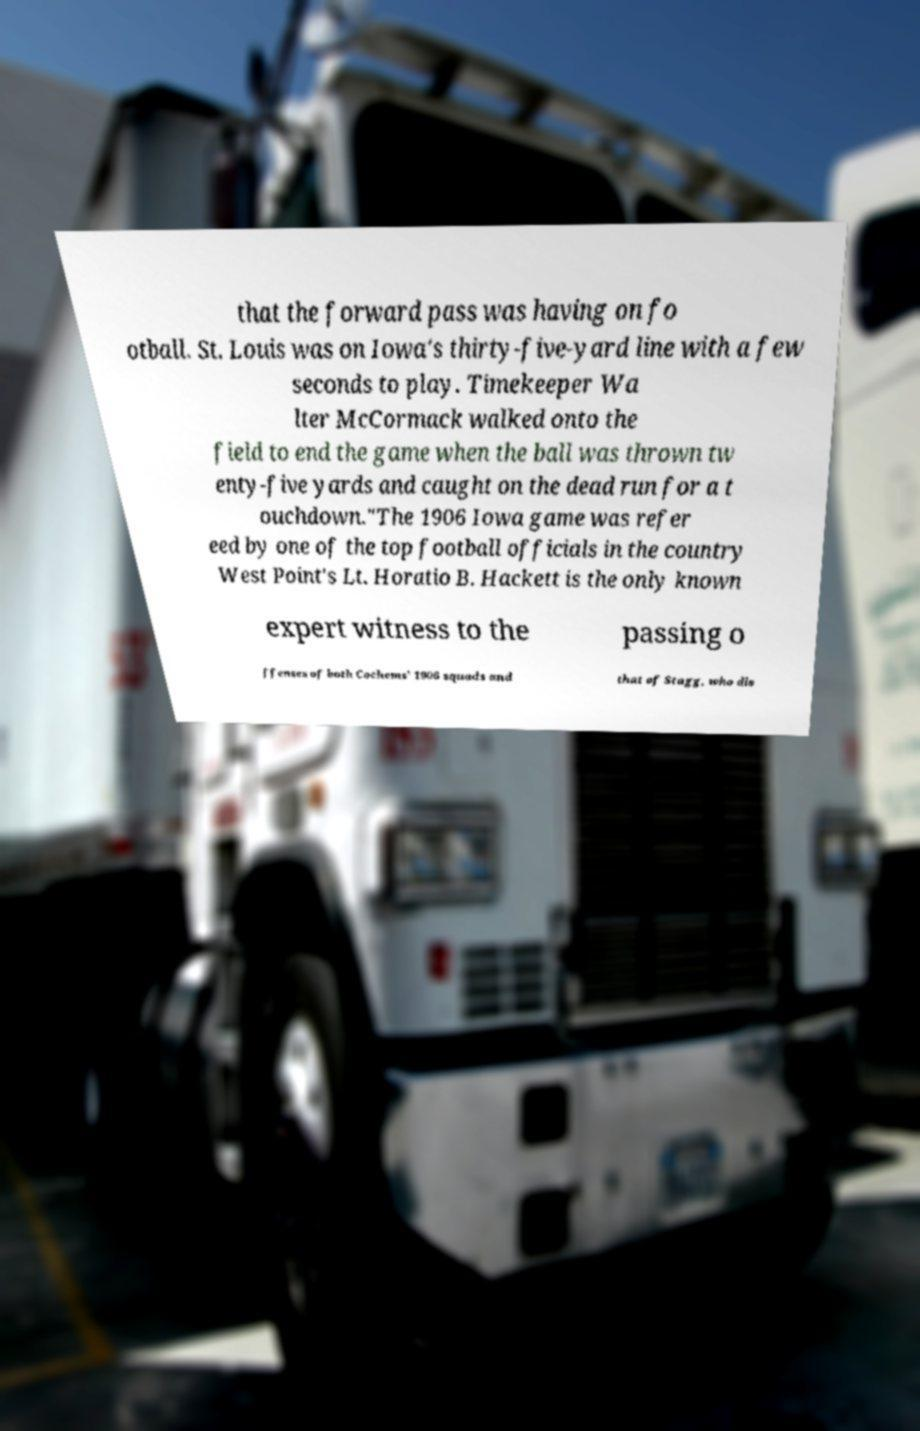Please read and relay the text visible in this image. What does it say? that the forward pass was having on fo otball. St. Louis was on Iowa's thirty-five-yard line with a few seconds to play. Timekeeper Wa lter McCormack walked onto the field to end the game when the ball was thrown tw enty-five yards and caught on the dead run for a t ouchdown."The 1906 Iowa game was refer eed by one of the top football officials in the country West Point's Lt. Horatio B. Hackett is the only known expert witness to the passing o ffenses of both Cochems' 1906 squads and that of Stagg, who dis 